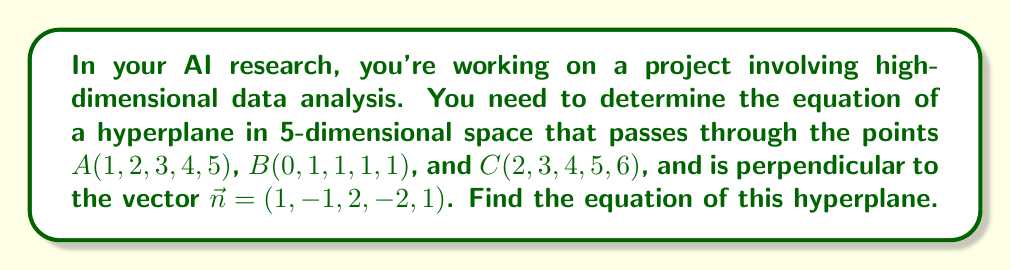Give your solution to this math problem. 1) The general equation of a hyperplane in 5-dimensional space is:

   $$ a_1x_1 + a_2x_2 + a_3x_3 + a_4x_4 + a_5x_5 = b $$

2) We're given that the hyperplane is perpendicular to $\vec{n} = (1, -1, 2, -2, 1)$. This means that $\vec{n}$ is the normal vector to our hyperplane. Therefore:

   $$ 1x_1 - 1x_2 + 2x_3 - 2x_4 + 1x_5 = b $$

3) Now we need to find $b$. We can do this by using any of the given points. Let's use point $A(1, 2, 3, 4, 5)$:

   $$ 1(1) - 1(2) + 2(3) - 2(4) + 1(5) = b $$
   $$ 1 - 2 + 6 - 8 + 5 = b $$
   $$ 2 = b $$

4) Therefore, the equation of the hyperplane is:

   $$ x_1 - x_2 + 2x_3 - 2x_4 + x_5 = 2 $$

5) To verify, we can check if the other points satisfy this equation:

   For $B(0, 1, 1, 1, 1)$:
   $$ 0 - 1 + 2(1) - 2(1) + 1 = 0 + 2 - 2 + 1 = 1 \neq 2 $$

   For $C(2, 3, 4, 5, 6)$:
   $$ 2 - 3 + 2(4) - 2(5) + 6 = 2 - 3 + 8 - 10 + 6 = 3 \neq 2 $$

6) Our equation doesn't satisfy points $B$ and $C$. This means that a hyperplane passing through all three points and perpendicular to the given vector doesn't exist. The question as stated has no solution.
Answer: No solution exists. The specified hyperplane cannot pass through all three points and be perpendicular to the given vector. 